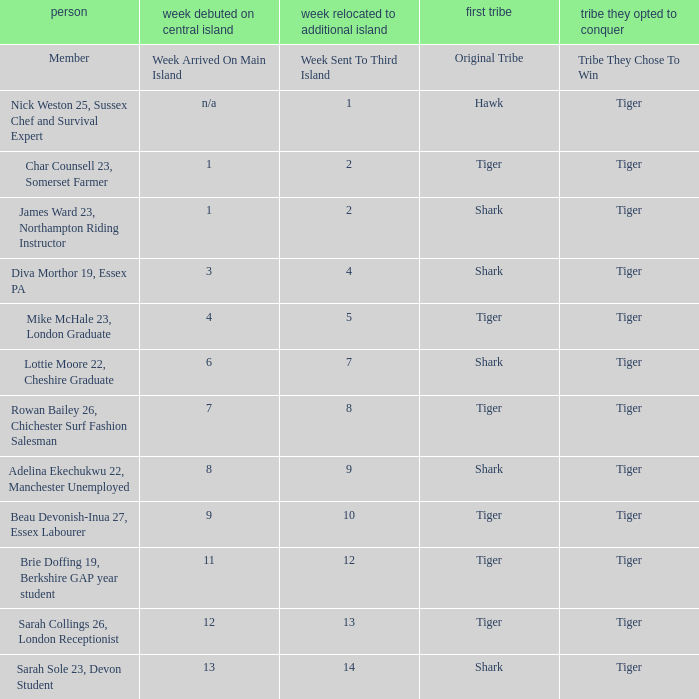Can you parse all the data within this table? {'header': ['person', 'week debuted on central island', 'week relocated to additional island', 'first tribe', 'tribe they opted to conquer'], 'rows': [['Member', 'Week Arrived On Main Island', 'Week Sent To Third Island', 'Original Tribe', 'Tribe They Chose To Win'], ['Nick Weston 25, Sussex Chef and Survival Expert', 'n/a', '1', 'Hawk', 'Tiger'], ['Char Counsell 23, Somerset Farmer', '1', '2', 'Tiger', 'Tiger'], ['James Ward 23, Northampton Riding Instructor', '1', '2', 'Shark', 'Tiger'], ['Diva Morthor 19, Essex PA', '3', '4', 'Shark', 'Tiger'], ['Mike McHale 23, London Graduate', '4', '5', 'Tiger', 'Tiger'], ['Lottie Moore 22, Cheshire Graduate', '6', '7', 'Shark', 'Tiger'], ['Rowan Bailey 26, Chichester Surf Fashion Salesman', '7', '8', 'Tiger', 'Tiger'], ['Adelina Ekechukwu 22, Manchester Unemployed', '8', '9', 'Shark', 'Tiger'], ['Beau Devonish-Inua 27, Essex Labourer', '9', '10', 'Tiger', 'Tiger'], ['Brie Doffing 19, Berkshire GAP year student', '11', '12', 'Tiger', 'Tiger'], ['Sarah Collings 26, London Receptionist', '12', '13', 'Tiger', 'Tiger'], ['Sarah Sole 23, Devon Student', '13', '14', 'Shark', 'Tiger']]} Who was sent to the third island in week 1? Nick Weston 25, Sussex Chef and Survival Expert. 